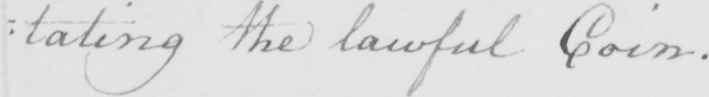Please transcribe the handwritten text in this image. : tating the lawful Coin . 